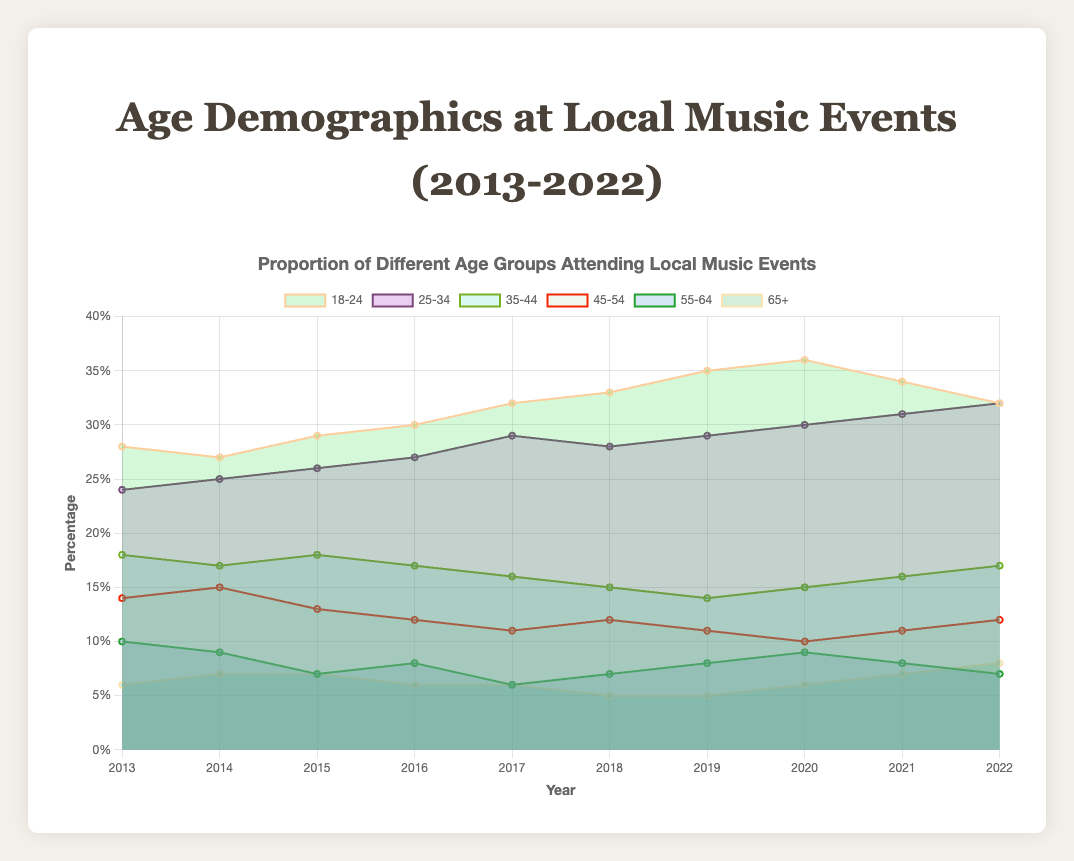What is the title of the chart? The title is usually located at the top of the chart and is displayed as 'Age Demographics at Local Music Events (2013-2022)'.
Answer: Age Demographics at Local Music Events (2013-2022) Which age group had the highest proportion in 2022? By observing the topmost section of the area chart corresponding to 2022, the "18-24" age group clearly has the largest area.
Answer: 18-24 How did the proportion of the 25-34 age group change from 2013 to 2022? Track the line and area that represent the 25-34 age group from 2013 to 2022. The value increased from 24% in 2013 to 32% in 2022.
Answer: Increased by 8% What was the lowest recorded proportion for the 35-44 age group in the last decade? Examine the "35-44" group data points across all years and find the minimum value, which is 14% in 2019.
Answer: 14% Which age group had the most significant decline between any two consecutive years? Reviewing all age groups data, the 55-64 age group showed the largest drop, declining from 10% in 2013 to 7% in 2015 (3% drop).
Answer: 55-64 Between 2020 and 2022, which age group saw the most growth in attendance proportion? Surveying all the age groups, "25-34" increased from 30% in 2020 to 32% in 2022, a 2% rise, which is the highest among all groups.
Answer: 25-34 In 2018, what was the combined proportion for age groups 45-54 and 55-64? Add the values for the age groups 45-54 (12%) and 55-64 (7%) for the year 2018. The combined proportion is 12% + 7% = 19%.
Answer: 19% Did any age group maintain the same proportion from 2013 to 2022? Compare the initial and final year values for each age group, and note that no age group had the same value in 2013 and 2022.
Answer: No Which age group had the most stable attendance, showing the least fluctuation over the years? Upon visually inspecting the chart, the "35-44" age group exhibits the least variation (ranging only between 14% to 18%).
Answer: 35-44 